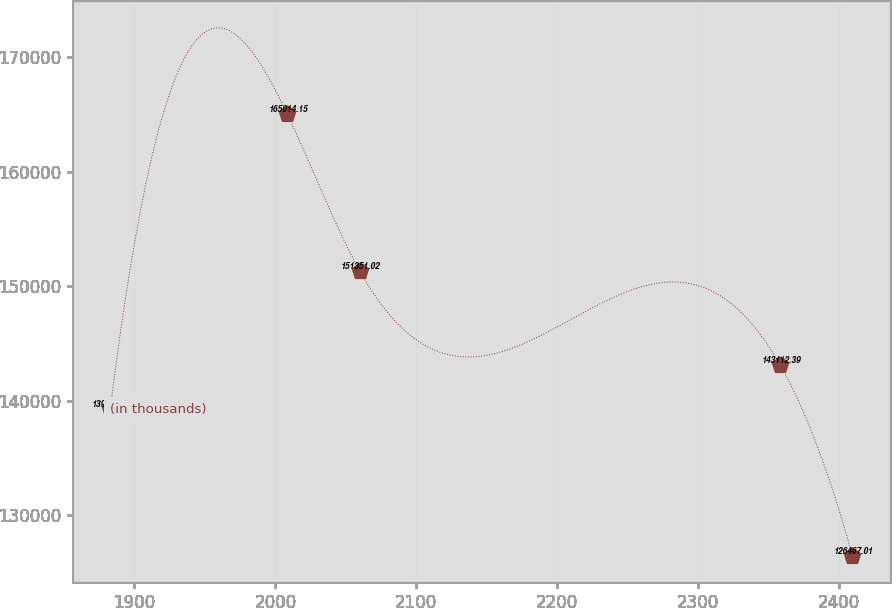Convert chart. <chart><loc_0><loc_0><loc_500><loc_500><line_chart><ecel><fcel>(in thousands)<nl><fcel>1882.81<fcel>139258<nl><fcel>2008.53<fcel>165014<nl><fcel>2059.82<fcel>151351<nl><fcel>2358.31<fcel>143112<nl><fcel>2409.6<fcel>126467<nl></chart> 